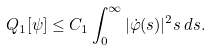<formula> <loc_0><loc_0><loc_500><loc_500>Q _ { 1 } [ \psi ] \leq C _ { 1 } \int _ { 0 } ^ { \infty } | \dot { \varphi } ( s ) | ^ { 2 } s \, d s .</formula> 